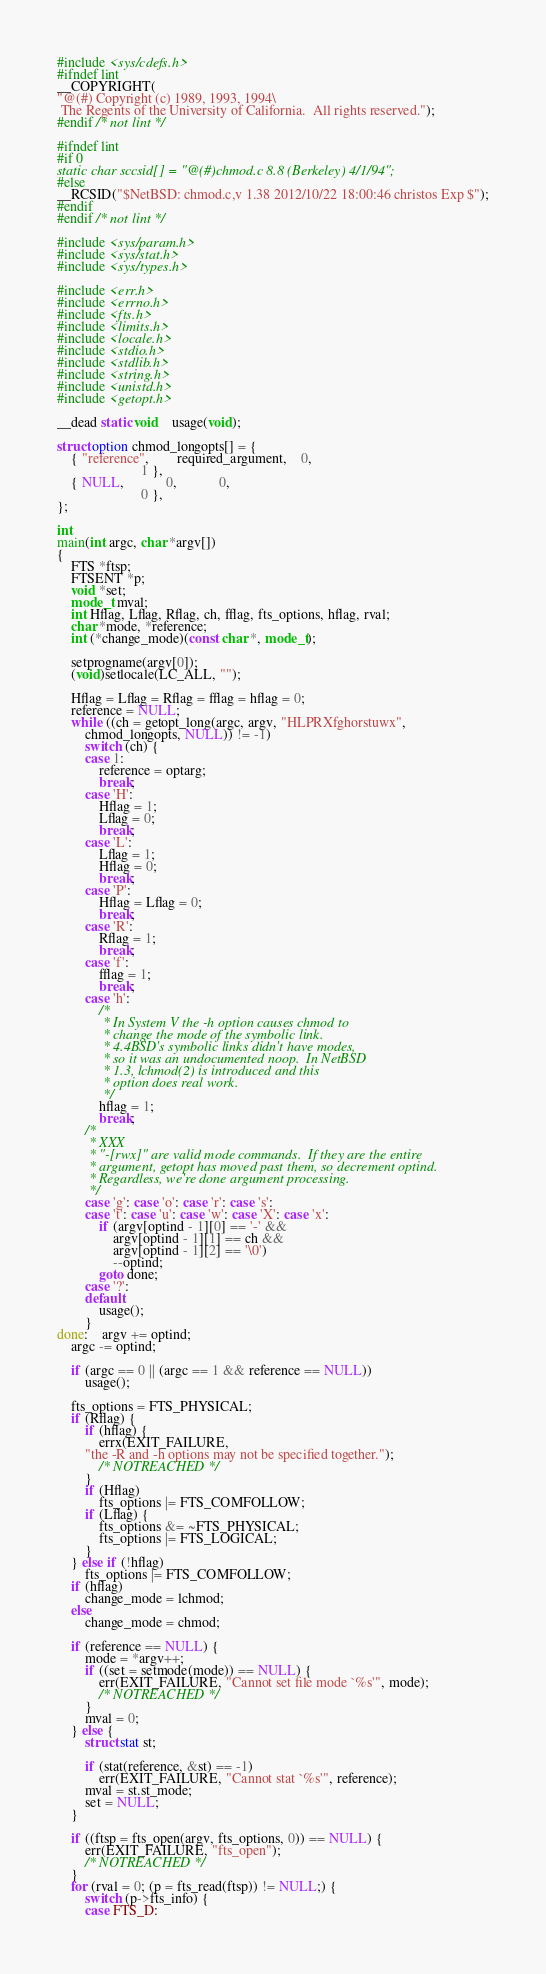<code> <loc_0><loc_0><loc_500><loc_500><_C_>#include <sys/cdefs.h>
#ifndef lint
__COPYRIGHT(
"@(#) Copyright (c) 1989, 1993, 1994\
 The Regents of the University of California.  All rights reserved.");
#endif /* not lint */

#ifndef lint
#if 0
static char sccsid[] = "@(#)chmod.c	8.8 (Berkeley) 4/1/94";
#else
__RCSID("$NetBSD: chmod.c,v 1.38 2012/10/22 18:00:46 christos Exp $");
#endif
#endif /* not lint */

#include <sys/param.h>
#include <sys/stat.h>
#include <sys/types.h>

#include <err.h>
#include <errno.h>
#include <fts.h>
#include <limits.h>
#include <locale.h>
#include <stdio.h>
#include <stdlib.h>
#include <string.h>
#include <unistd.h>
#include <getopt.h>

__dead static void	usage(void);

struct option chmod_longopts[] = {
	{ "reference",		required_argument,	0,
						1 },
	{ NULL,			0,			0,
						0 },
};

int
main(int argc, char *argv[])
{
	FTS *ftsp;
	FTSENT *p;
	void *set;
	mode_t mval;
	int Hflag, Lflag, Rflag, ch, fflag, fts_options, hflag, rval;
	char *mode, *reference;
	int (*change_mode)(const char *, mode_t);

	setprogname(argv[0]);
	(void)setlocale(LC_ALL, "");

	Hflag = Lflag = Rflag = fflag = hflag = 0;
	reference = NULL;
	while ((ch = getopt_long(argc, argv, "HLPRXfghorstuwx",
	    chmod_longopts, NULL)) != -1)
		switch (ch) {
		case 1:
			reference = optarg;
			break;
		case 'H':
			Hflag = 1;
			Lflag = 0;
			break;
		case 'L':
			Lflag = 1;
			Hflag = 0;
			break;
		case 'P':
			Hflag = Lflag = 0;
			break;
		case 'R':
			Rflag = 1;
			break;
		case 'f':
			fflag = 1;
			break;
		case 'h':
			/*
			 * In System V the -h option causes chmod to
			 * change the mode of the symbolic link.
			 * 4.4BSD's symbolic links didn't have modes,
			 * so it was an undocumented noop.  In NetBSD
			 * 1.3, lchmod(2) is introduced and this
			 * option does real work.
			 */
			hflag = 1;
			break;
		/*
		 * XXX
		 * "-[rwx]" are valid mode commands.  If they are the entire
		 * argument, getopt has moved past them, so decrement optind.
		 * Regardless, we're done argument processing.
		 */
		case 'g': case 'o': case 'r': case 's':
		case 't': case 'u': case 'w': case 'X': case 'x':
			if (argv[optind - 1][0] == '-' &&
			    argv[optind - 1][1] == ch &&
			    argv[optind - 1][2] == '\0')
				--optind;
			goto done;
		case '?':
		default:
			usage();
		}
done:	argv += optind;
	argc -= optind;

	if (argc == 0 || (argc == 1 && reference == NULL))
		usage();

	fts_options = FTS_PHYSICAL;
	if (Rflag) {
		if (hflag) {
			errx(EXIT_FAILURE,
		"the -R and -h options may not be specified together.");
			/* NOTREACHED */
		}
		if (Hflag)
			fts_options |= FTS_COMFOLLOW;
		if (Lflag) {
			fts_options &= ~FTS_PHYSICAL;
			fts_options |= FTS_LOGICAL;
		}
	} else if (!hflag)
		fts_options |= FTS_COMFOLLOW;
	if (hflag)
		change_mode = lchmod;
	else
		change_mode = chmod;

	if (reference == NULL) {
		mode = *argv++;
		if ((set = setmode(mode)) == NULL) {
			err(EXIT_FAILURE, "Cannot set file mode `%s'", mode);
			/* NOTREACHED */
		}
		mval = 0;
	} else {
		struct stat st;

		if (stat(reference, &st) == -1)
			err(EXIT_FAILURE, "Cannot stat `%s'", reference);
		mval = st.st_mode;
		set = NULL;
	}

	if ((ftsp = fts_open(argv, fts_options, 0)) == NULL) {
		err(EXIT_FAILURE, "fts_open");
		/* NOTREACHED */
	}
	for (rval = 0; (p = fts_read(ftsp)) != NULL;) {
		switch (p->fts_info) {
		case FTS_D:</code> 